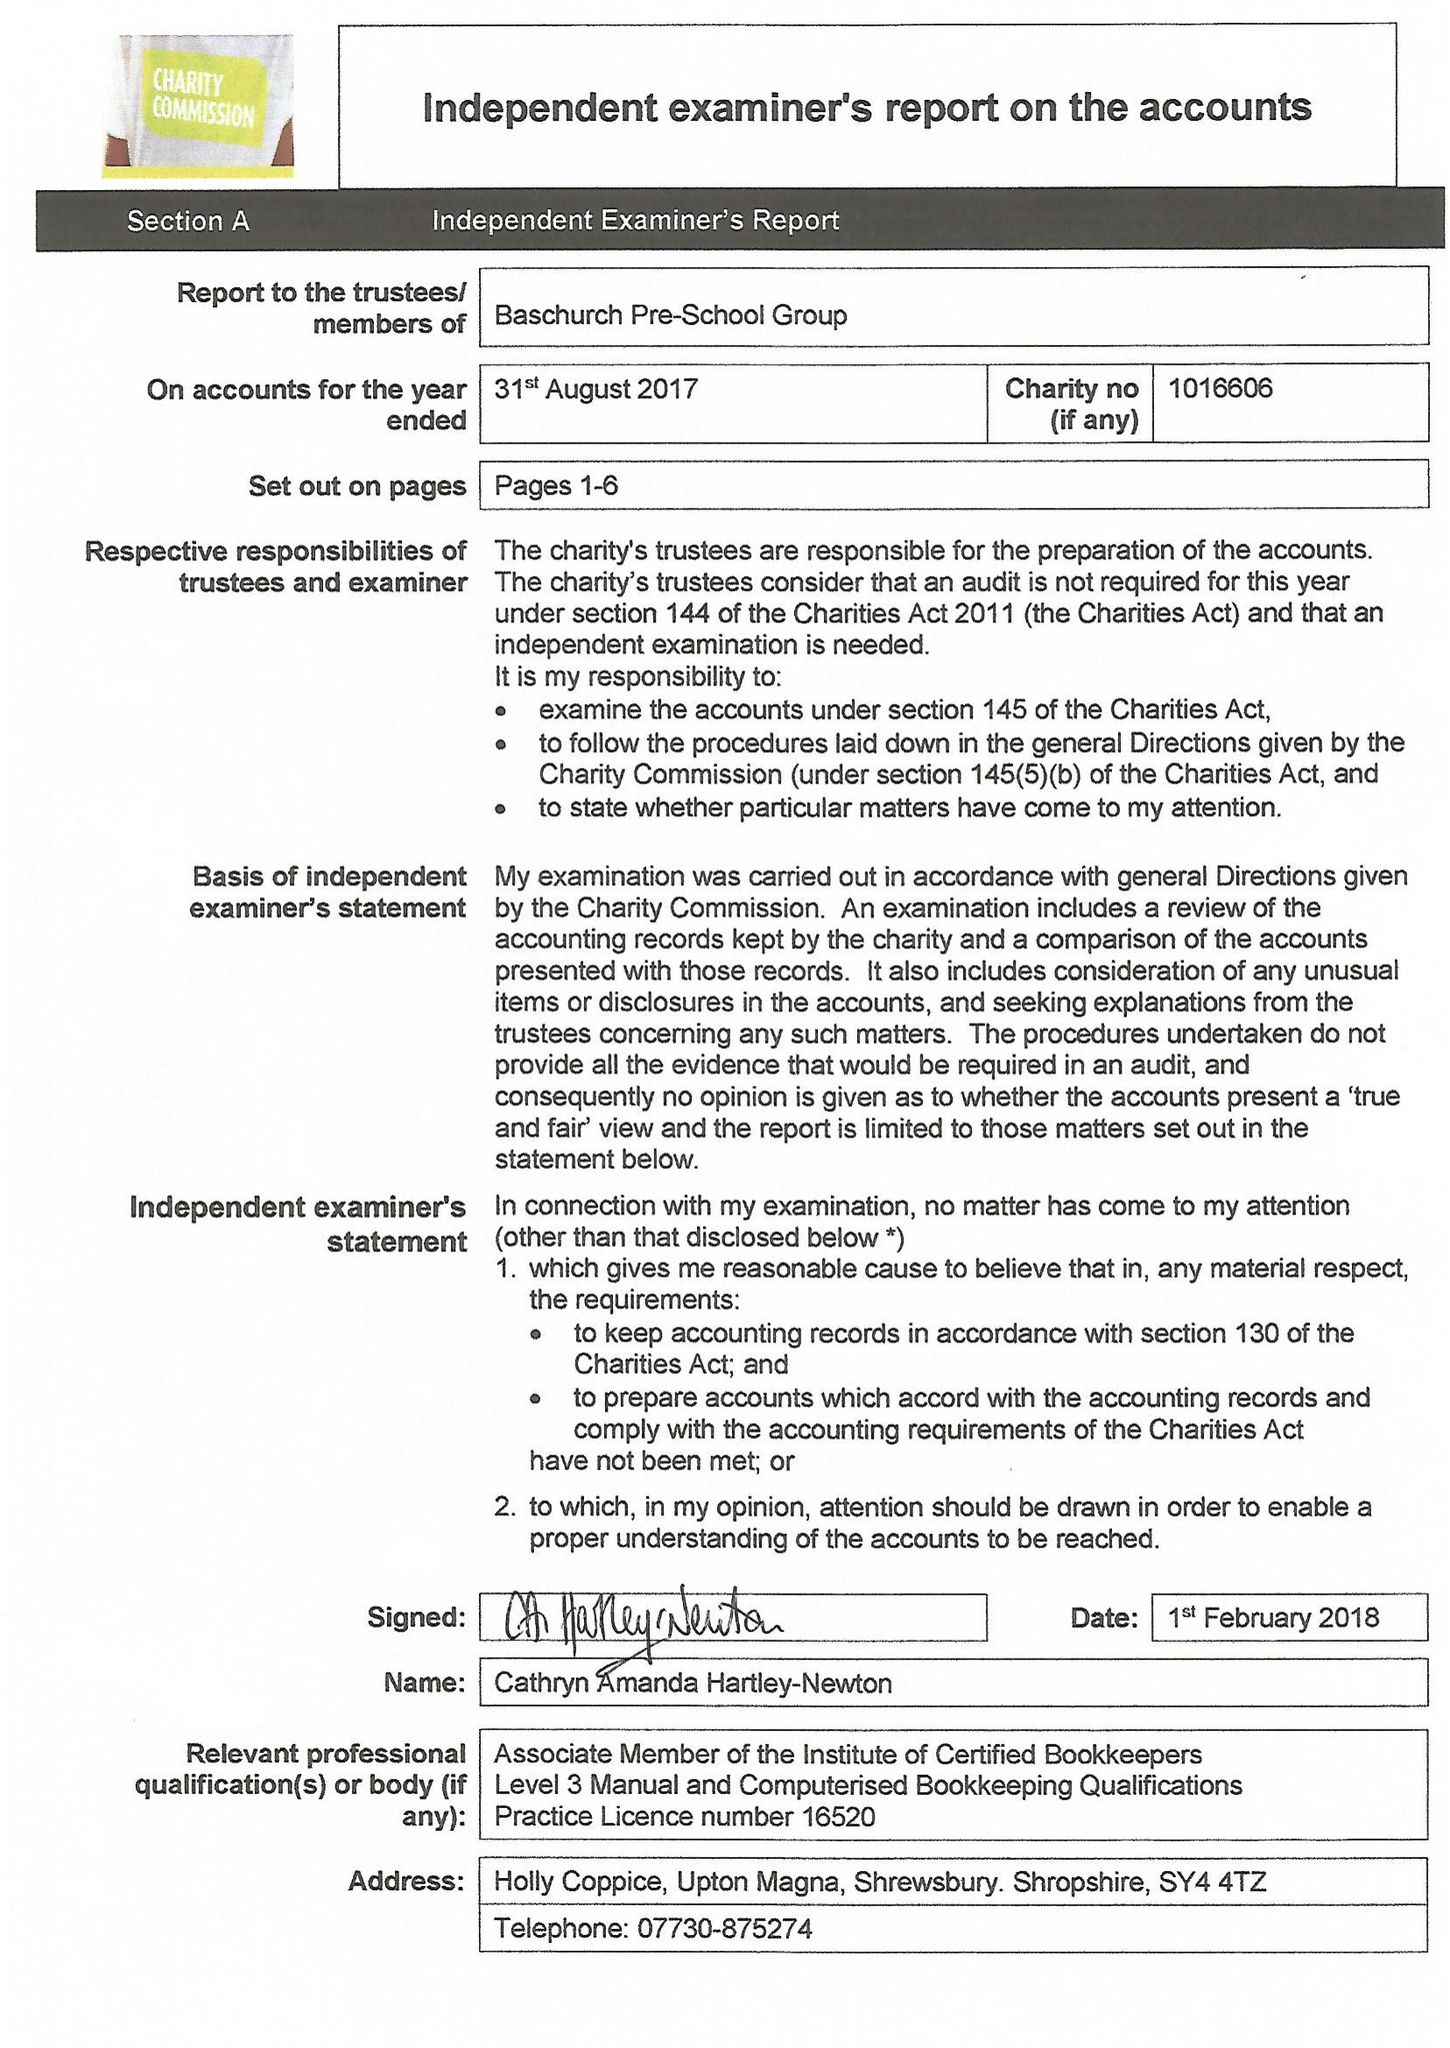What is the value for the address__post_town?
Answer the question using a single word or phrase. MEIFOD 